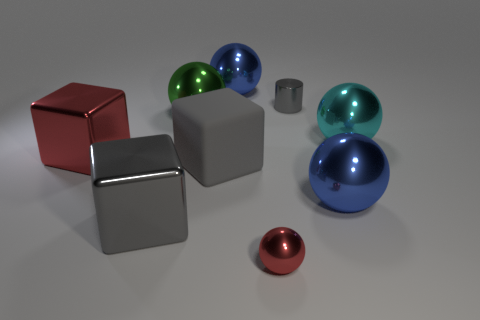Subtract all large spheres. How many spheres are left? 1 Subtract all cyan balls. How many balls are left? 4 Subtract 2 balls. How many balls are left? 3 Add 5 red shiny spheres. How many red shiny spheres exist? 6 Subtract 0 yellow cubes. How many objects are left? 9 Subtract all spheres. How many objects are left? 4 Subtract all yellow blocks. Subtract all blue cylinders. How many blocks are left? 3 Subtract all purple cylinders. How many red blocks are left? 1 Subtract all small yellow matte blocks. Subtract all big green metal spheres. How many objects are left? 8 Add 1 cyan things. How many cyan things are left? 2 